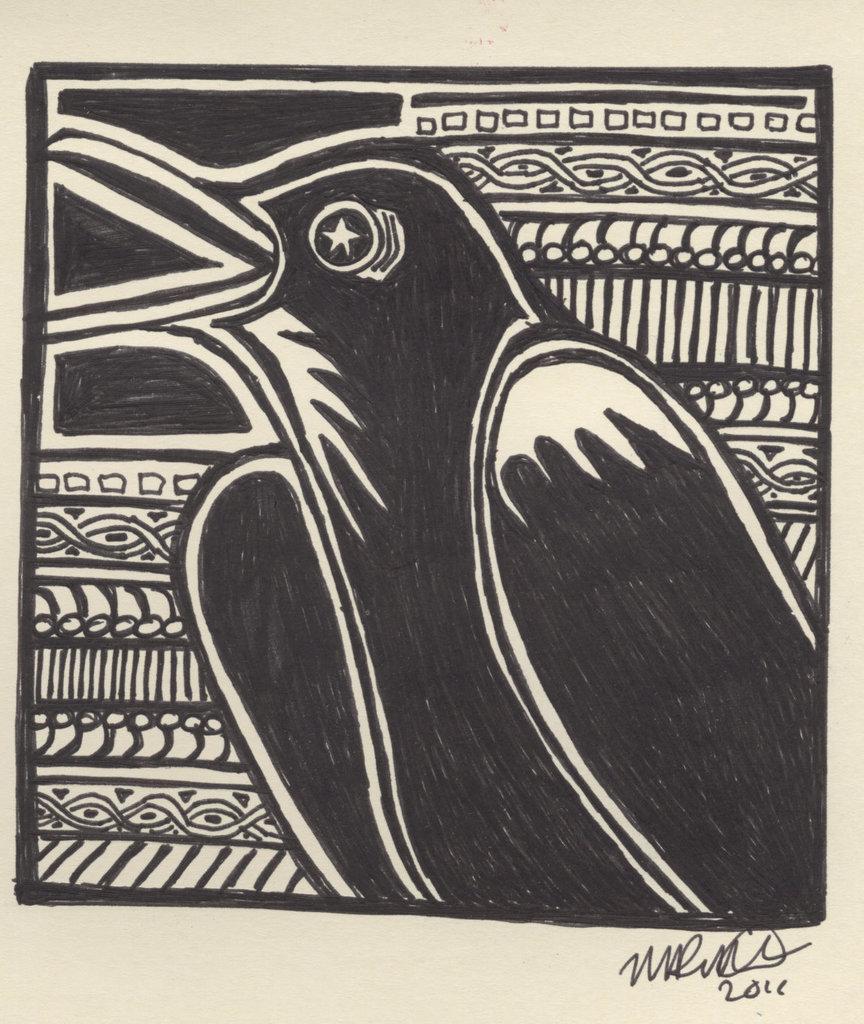Could you give a brief overview of what you see in this image? In this image we can see a sketch of a bird on the poster. 